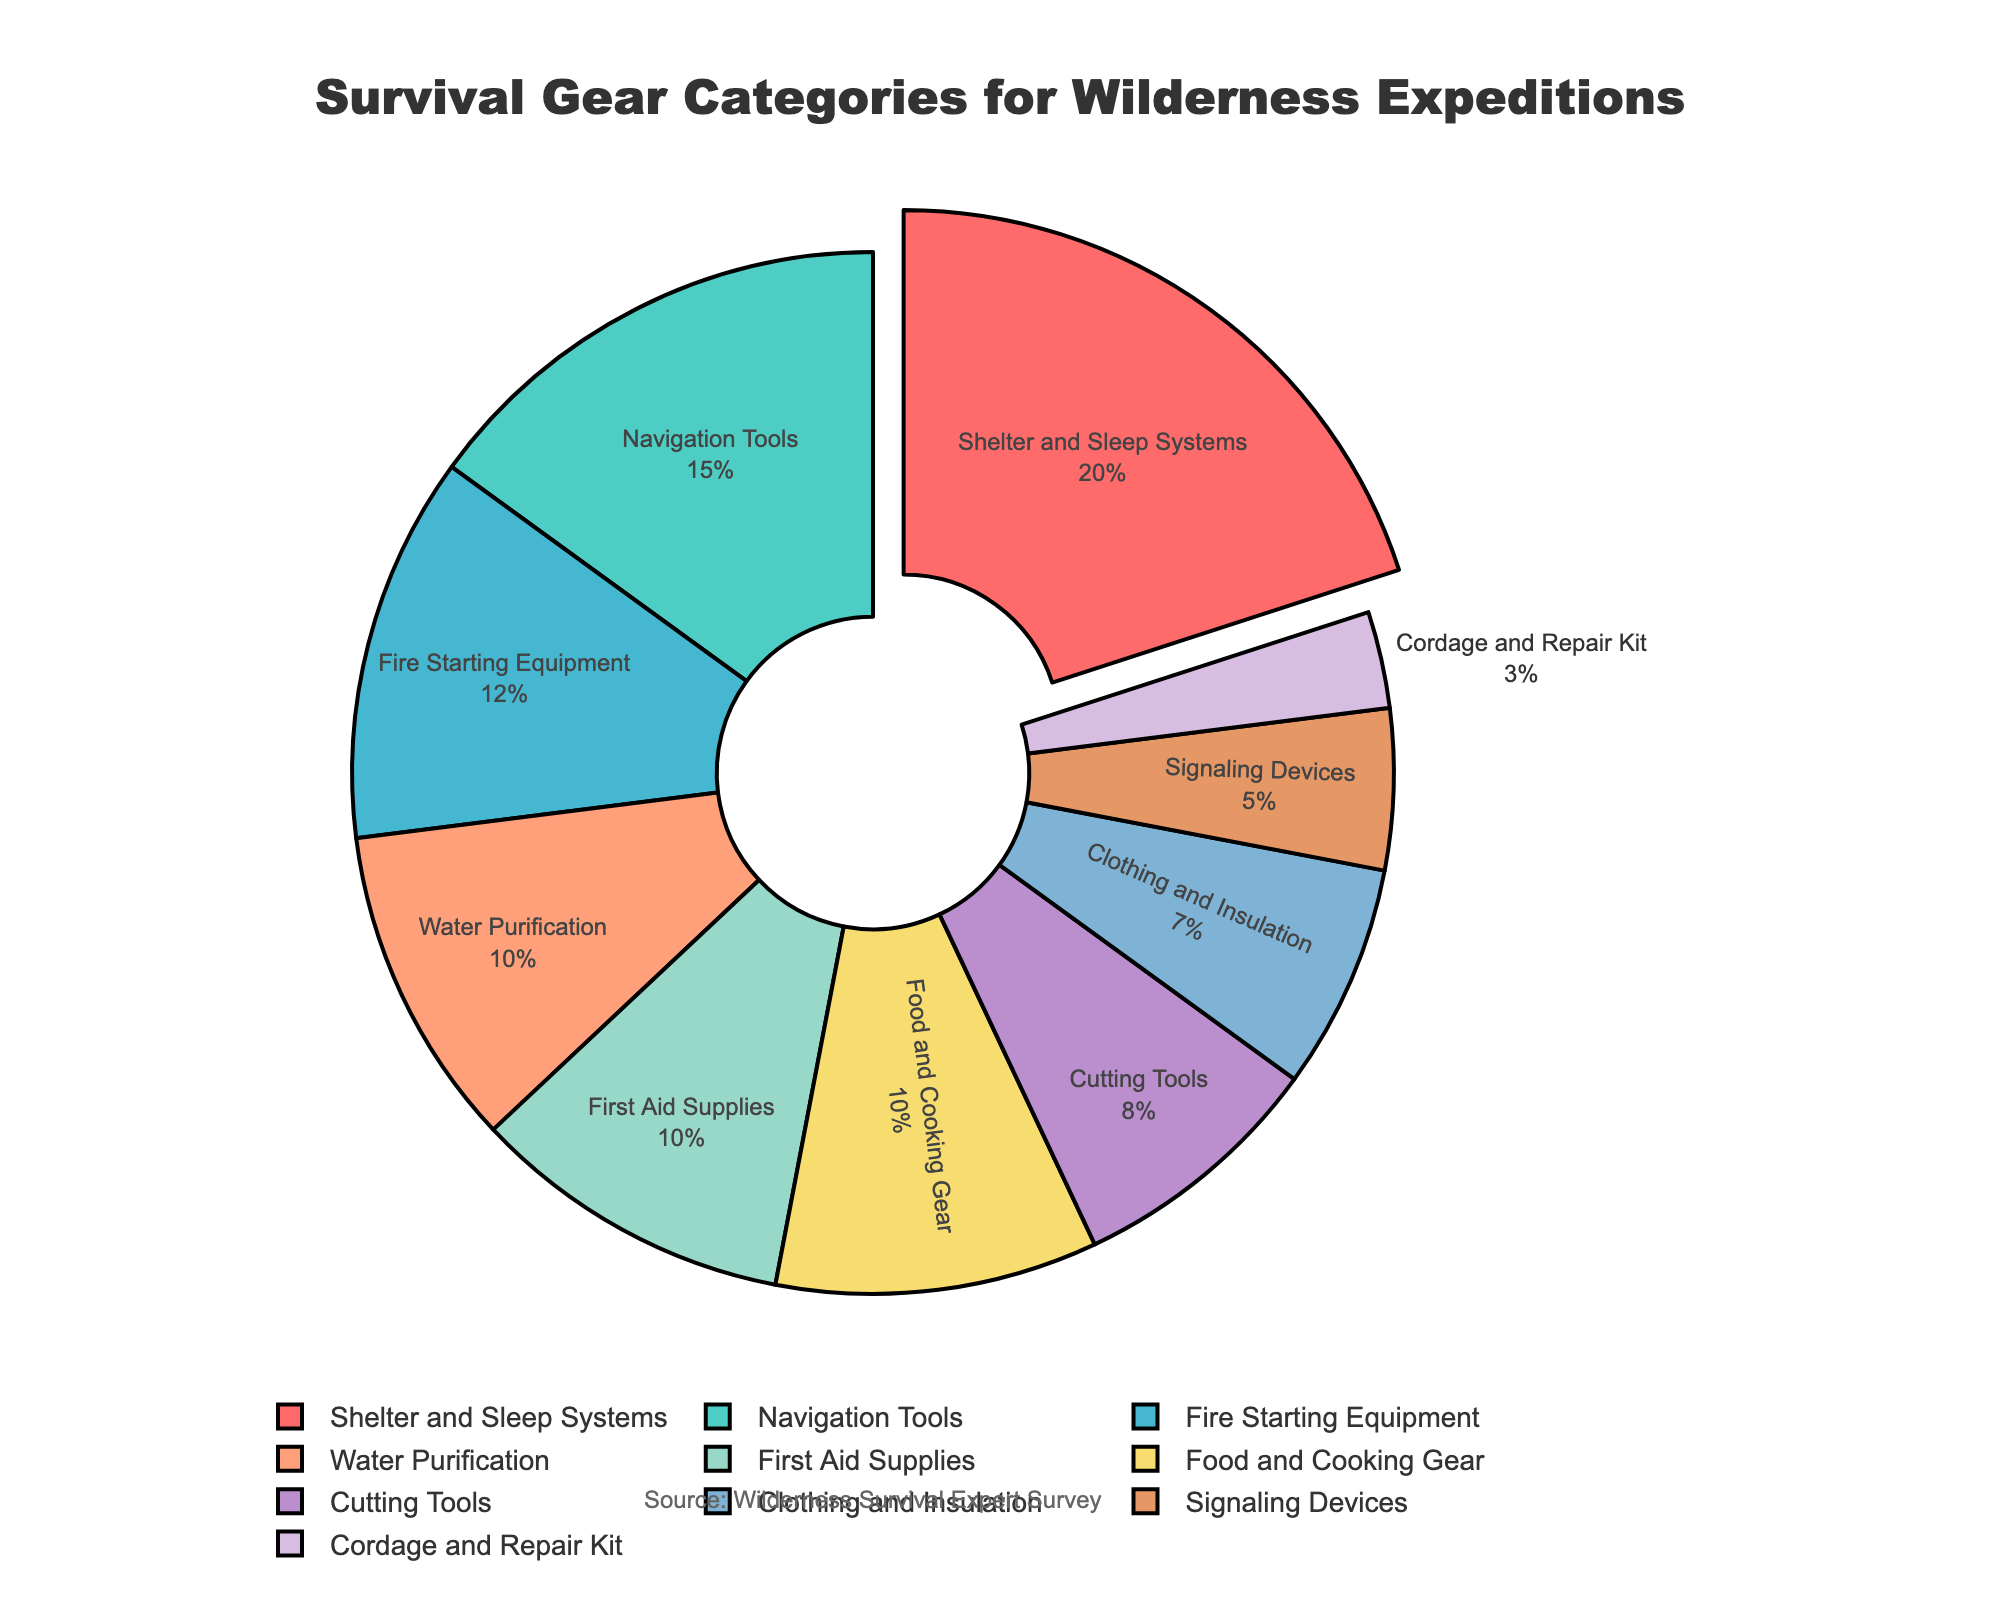What's the most significant category of survival gear? The largest segment of the pie chart, visually pulled out from the rest, represents the most significant category. This segment is labeled "Shelter and Sleep Systems," which covers 20% of the total gear.
Answer: Shelter and Sleep Systems Which category covers the smallest percentage of survival gear? The smallest segment of the pie chart represents the least significant category. This segment is labeled "Cordage and Repair Kit," accounting for 3% of the total gear.
Answer: Cordage and Repair Kit How much larger is the "Shelter and Sleep Systems" category compared to "Signaling Devices"? "Shelter and Sleep Systems" covers 20% while "Signaling Devices" covers 5%. The difference is calculated as 20% - 5% = 15%.
Answer: 15% What's the combined percentage of "Navigation Tools" and "Water Purification"? "Navigation Tools" covers 15% and "Water Purification" covers 10%. The combined percentage is 15% + 10% = 25%.
Answer: 25% Which categories together make up 30% of the gear? The category "Cutting Tools" (8%) combined with "Clothing and Insulation" (7%) and "Signaling Devices" (5%) equals 8% + 7% + 5% = 20%. Since "Navigation Tools" (15%) and "Water Purification" (10%) exceed 30% (25%), the correct combination is "Navigation Tools" (15%) + "Fire Starting Equipment" (12%) + "Cordage and Repair Kit" (3%). Together these make 15% + 12% + 3% = 30%.
Answer: Navigation Tools, Fire Starting Equipment, Cordage and Repair Kit Is there an even distribution of categories in the chart? The segments vary significantly in size, with the largest category ("Shelter and Sleep Systems") accounting for 20% and the smallest category ("Cordage and Repair Kit") accounting for 3%. Thus, the distribution is not even.
Answer: No Which category is represented by the green segment? Observing the color of the segments, the green segment corresponds to "Navigation Tools" with 15%.
Answer: Navigation Tools What is the total percentage for "Food and Cooking Gear," "First Aid Supplies," and "Water Purification"? "Food and Cooking Gear" takes up 10%, "First Aid Supplies" also covers 10%, and "Water Purification" is 10%. Their total percentage is 10% + 10% + 10% = 30%.
Answer: 30% Are "Clothing and Insulation" and "Cutting Tools" segments equal? The segment representing "Clothing and Insulation" is 7%, whereas "Cutting Tools" is 8%. These values are close but not equal.
Answer: No What is the average percentage of "First Aid Supplies," "Fire Starting Equipment," and "Food and Cooking Gear"? The percentages are 10% for "First Aid Supplies," 12% for "Fire Starting Equipment," and 10% for "Food and Cooking Gear." The average is (10% + 12% + 10%) / 3 = 32% / 3 ≈ 10.67%.
Answer: 10.67% 